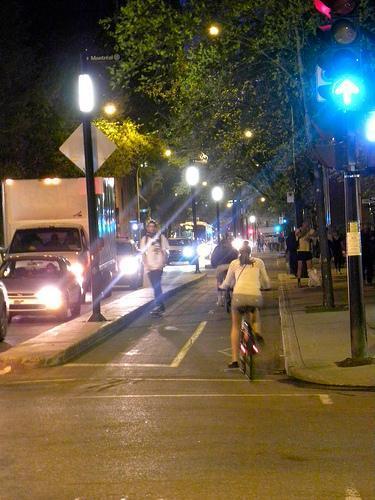How many people are on bikes?
Give a very brief answer. 2. 